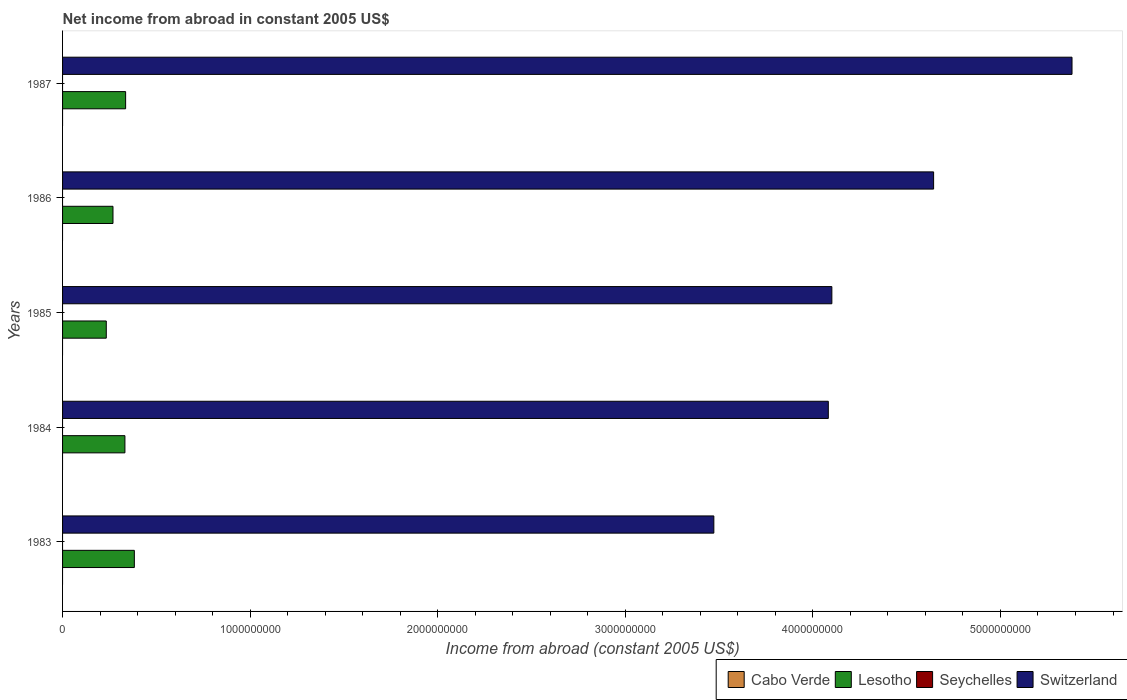Are the number of bars on each tick of the Y-axis equal?
Give a very brief answer. Yes. In how many cases, is the number of bars for a given year not equal to the number of legend labels?
Provide a short and direct response. 5. What is the net income from abroad in Cabo Verde in 1987?
Give a very brief answer. 0. Across all years, what is the maximum net income from abroad in Lesotho?
Keep it short and to the point. 3.83e+08. Across all years, what is the minimum net income from abroad in Lesotho?
Your answer should be very brief. 2.33e+08. What is the difference between the net income from abroad in Lesotho in 1983 and that in 1985?
Give a very brief answer. 1.50e+08. What is the difference between the net income from abroad in Cabo Verde in 1986 and the net income from abroad in Switzerland in 1984?
Offer a very short reply. -4.08e+09. In the year 1983, what is the difference between the net income from abroad in Lesotho and net income from abroad in Switzerland?
Provide a succinct answer. -3.09e+09. What is the ratio of the net income from abroad in Switzerland in 1983 to that in 1986?
Provide a short and direct response. 0.75. Is the difference between the net income from abroad in Lesotho in 1984 and 1986 greater than the difference between the net income from abroad in Switzerland in 1984 and 1986?
Provide a succinct answer. Yes. What is the difference between the highest and the second highest net income from abroad in Switzerland?
Your answer should be compact. 7.38e+08. What is the difference between the highest and the lowest net income from abroad in Lesotho?
Offer a very short reply. 1.50e+08. Is it the case that in every year, the sum of the net income from abroad in Lesotho and net income from abroad in Seychelles is greater than the sum of net income from abroad in Switzerland and net income from abroad in Cabo Verde?
Keep it short and to the point. No. How many bars are there?
Ensure brevity in your answer.  10. Are all the bars in the graph horizontal?
Ensure brevity in your answer.  Yes. How many years are there in the graph?
Your answer should be compact. 5. Are the values on the major ticks of X-axis written in scientific E-notation?
Keep it short and to the point. No. How many legend labels are there?
Your response must be concise. 4. What is the title of the graph?
Offer a very short reply. Net income from abroad in constant 2005 US$. What is the label or title of the X-axis?
Offer a very short reply. Income from abroad (constant 2005 US$). What is the Income from abroad (constant 2005 US$) in Lesotho in 1983?
Ensure brevity in your answer.  3.83e+08. What is the Income from abroad (constant 2005 US$) in Seychelles in 1983?
Your answer should be compact. 0. What is the Income from abroad (constant 2005 US$) of Switzerland in 1983?
Your answer should be very brief. 3.47e+09. What is the Income from abroad (constant 2005 US$) in Lesotho in 1984?
Provide a succinct answer. 3.32e+08. What is the Income from abroad (constant 2005 US$) in Seychelles in 1984?
Provide a succinct answer. 0. What is the Income from abroad (constant 2005 US$) of Switzerland in 1984?
Your answer should be very brief. 4.08e+09. What is the Income from abroad (constant 2005 US$) of Lesotho in 1985?
Ensure brevity in your answer.  2.33e+08. What is the Income from abroad (constant 2005 US$) in Seychelles in 1985?
Your response must be concise. 0. What is the Income from abroad (constant 2005 US$) in Switzerland in 1985?
Offer a very short reply. 4.10e+09. What is the Income from abroad (constant 2005 US$) of Cabo Verde in 1986?
Offer a very short reply. 0. What is the Income from abroad (constant 2005 US$) of Lesotho in 1986?
Your response must be concise. 2.69e+08. What is the Income from abroad (constant 2005 US$) in Seychelles in 1986?
Provide a succinct answer. 0. What is the Income from abroad (constant 2005 US$) in Switzerland in 1986?
Make the answer very short. 4.64e+09. What is the Income from abroad (constant 2005 US$) in Lesotho in 1987?
Ensure brevity in your answer.  3.36e+08. What is the Income from abroad (constant 2005 US$) of Switzerland in 1987?
Offer a very short reply. 5.38e+09. Across all years, what is the maximum Income from abroad (constant 2005 US$) of Lesotho?
Make the answer very short. 3.83e+08. Across all years, what is the maximum Income from abroad (constant 2005 US$) of Switzerland?
Offer a terse response. 5.38e+09. Across all years, what is the minimum Income from abroad (constant 2005 US$) in Lesotho?
Provide a succinct answer. 2.33e+08. Across all years, what is the minimum Income from abroad (constant 2005 US$) of Switzerland?
Provide a succinct answer. 3.47e+09. What is the total Income from abroad (constant 2005 US$) in Lesotho in the graph?
Your answer should be compact. 1.55e+09. What is the total Income from abroad (constant 2005 US$) in Seychelles in the graph?
Offer a terse response. 0. What is the total Income from abroad (constant 2005 US$) of Switzerland in the graph?
Keep it short and to the point. 2.17e+1. What is the difference between the Income from abroad (constant 2005 US$) of Lesotho in 1983 and that in 1984?
Your answer should be compact. 5.02e+07. What is the difference between the Income from abroad (constant 2005 US$) of Switzerland in 1983 and that in 1984?
Your answer should be very brief. -6.10e+08. What is the difference between the Income from abroad (constant 2005 US$) in Lesotho in 1983 and that in 1985?
Make the answer very short. 1.50e+08. What is the difference between the Income from abroad (constant 2005 US$) in Switzerland in 1983 and that in 1985?
Provide a succinct answer. -6.29e+08. What is the difference between the Income from abroad (constant 2005 US$) of Lesotho in 1983 and that in 1986?
Make the answer very short. 1.14e+08. What is the difference between the Income from abroad (constant 2005 US$) of Switzerland in 1983 and that in 1986?
Keep it short and to the point. -1.17e+09. What is the difference between the Income from abroad (constant 2005 US$) of Lesotho in 1983 and that in 1987?
Your answer should be compact. 4.65e+07. What is the difference between the Income from abroad (constant 2005 US$) in Switzerland in 1983 and that in 1987?
Offer a terse response. -1.91e+09. What is the difference between the Income from abroad (constant 2005 US$) of Lesotho in 1984 and that in 1985?
Ensure brevity in your answer.  9.94e+07. What is the difference between the Income from abroad (constant 2005 US$) in Switzerland in 1984 and that in 1985?
Offer a terse response. -1.90e+07. What is the difference between the Income from abroad (constant 2005 US$) in Lesotho in 1984 and that in 1986?
Your answer should be compact. 6.36e+07. What is the difference between the Income from abroad (constant 2005 US$) of Switzerland in 1984 and that in 1986?
Make the answer very short. -5.61e+08. What is the difference between the Income from abroad (constant 2005 US$) of Lesotho in 1984 and that in 1987?
Provide a short and direct response. -3.77e+06. What is the difference between the Income from abroad (constant 2005 US$) of Switzerland in 1984 and that in 1987?
Keep it short and to the point. -1.30e+09. What is the difference between the Income from abroad (constant 2005 US$) of Lesotho in 1985 and that in 1986?
Offer a terse response. -3.58e+07. What is the difference between the Income from abroad (constant 2005 US$) in Switzerland in 1985 and that in 1986?
Give a very brief answer. -5.42e+08. What is the difference between the Income from abroad (constant 2005 US$) in Lesotho in 1985 and that in 1987?
Offer a terse response. -1.03e+08. What is the difference between the Income from abroad (constant 2005 US$) in Switzerland in 1985 and that in 1987?
Your response must be concise. -1.28e+09. What is the difference between the Income from abroad (constant 2005 US$) in Lesotho in 1986 and that in 1987?
Your response must be concise. -6.73e+07. What is the difference between the Income from abroad (constant 2005 US$) in Switzerland in 1986 and that in 1987?
Provide a succinct answer. -7.38e+08. What is the difference between the Income from abroad (constant 2005 US$) of Lesotho in 1983 and the Income from abroad (constant 2005 US$) of Switzerland in 1984?
Ensure brevity in your answer.  -3.70e+09. What is the difference between the Income from abroad (constant 2005 US$) in Lesotho in 1983 and the Income from abroad (constant 2005 US$) in Switzerland in 1985?
Keep it short and to the point. -3.72e+09. What is the difference between the Income from abroad (constant 2005 US$) of Lesotho in 1983 and the Income from abroad (constant 2005 US$) of Switzerland in 1986?
Your response must be concise. -4.26e+09. What is the difference between the Income from abroad (constant 2005 US$) in Lesotho in 1983 and the Income from abroad (constant 2005 US$) in Switzerland in 1987?
Keep it short and to the point. -5.00e+09. What is the difference between the Income from abroad (constant 2005 US$) in Lesotho in 1984 and the Income from abroad (constant 2005 US$) in Switzerland in 1985?
Give a very brief answer. -3.77e+09. What is the difference between the Income from abroad (constant 2005 US$) in Lesotho in 1984 and the Income from abroad (constant 2005 US$) in Switzerland in 1986?
Provide a short and direct response. -4.31e+09. What is the difference between the Income from abroad (constant 2005 US$) of Lesotho in 1984 and the Income from abroad (constant 2005 US$) of Switzerland in 1987?
Offer a terse response. -5.05e+09. What is the difference between the Income from abroad (constant 2005 US$) of Lesotho in 1985 and the Income from abroad (constant 2005 US$) of Switzerland in 1986?
Ensure brevity in your answer.  -4.41e+09. What is the difference between the Income from abroad (constant 2005 US$) in Lesotho in 1985 and the Income from abroad (constant 2005 US$) in Switzerland in 1987?
Your answer should be compact. -5.15e+09. What is the difference between the Income from abroad (constant 2005 US$) of Lesotho in 1986 and the Income from abroad (constant 2005 US$) of Switzerland in 1987?
Ensure brevity in your answer.  -5.11e+09. What is the average Income from abroad (constant 2005 US$) in Lesotho per year?
Provide a short and direct response. 3.11e+08. What is the average Income from abroad (constant 2005 US$) in Seychelles per year?
Make the answer very short. 0. What is the average Income from abroad (constant 2005 US$) of Switzerland per year?
Your answer should be compact. 4.34e+09. In the year 1983, what is the difference between the Income from abroad (constant 2005 US$) of Lesotho and Income from abroad (constant 2005 US$) of Switzerland?
Your answer should be compact. -3.09e+09. In the year 1984, what is the difference between the Income from abroad (constant 2005 US$) in Lesotho and Income from abroad (constant 2005 US$) in Switzerland?
Provide a succinct answer. -3.75e+09. In the year 1985, what is the difference between the Income from abroad (constant 2005 US$) in Lesotho and Income from abroad (constant 2005 US$) in Switzerland?
Offer a terse response. -3.87e+09. In the year 1986, what is the difference between the Income from abroad (constant 2005 US$) of Lesotho and Income from abroad (constant 2005 US$) of Switzerland?
Your answer should be very brief. -4.37e+09. In the year 1987, what is the difference between the Income from abroad (constant 2005 US$) in Lesotho and Income from abroad (constant 2005 US$) in Switzerland?
Keep it short and to the point. -5.05e+09. What is the ratio of the Income from abroad (constant 2005 US$) of Lesotho in 1983 to that in 1984?
Make the answer very short. 1.15. What is the ratio of the Income from abroad (constant 2005 US$) of Switzerland in 1983 to that in 1984?
Ensure brevity in your answer.  0.85. What is the ratio of the Income from abroad (constant 2005 US$) in Lesotho in 1983 to that in 1985?
Make the answer very short. 1.64. What is the ratio of the Income from abroad (constant 2005 US$) in Switzerland in 1983 to that in 1985?
Provide a succinct answer. 0.85. What is the ratio of the Income from abroad (constant 2005 US$) of Lesotho in 1983 to that in 1986?
Your answer should be very brief. 1.42. What is the ratio of the Income from abroad (constant 2005 US$) in Switzerland in 1983 to that in 1986?
Your answer should be very brief. 0.75. What is the ratio of the Income from abroad (constant 2005 US$) in Lesotho in 1983 to that in 1987?
Provide a succinct answer. 1.14. What is the ratio of the Income from abroad (constant 2005 US$) in Switzerland in 1983 to that in 1987?
Give a very brief answer. 0.65. What is the ratio of the Income from abroad (constant 2005 US$) of Lesotho in 1984 to that in 1985?
Your answer should be very brief. 1.43. What is the ratio of the Income from abroad (constant 2005 US$) in Switzerland in 1984 to that in 1985?
Ensure brevity in your answer.  1. What is the ratio of the Income from abroad (constant 2005 US$) in Lesotho in 1984 to that in 1986?
Offer a terse response. 1.24. What is the ratio of the Income from abroad (constant 2005 US$) in Switzerland in 1984 to that in 1986?
Offer a terse response. 0.88. What is the ratio of the Income from abroad (constant 2005 US$) in Switzerland in 1984 to that in 1987?
Offer a terse response. 0.76. What is the ratio of the Income from abroad (constant 2005 US$) in Lesotho in 1985 to that in 1986?
Your answer should be very brief. 0.87. What is the ratio of the Income from abroad (constant 2005 US$) of Switzerland in 1985 to that in 1986?
Provide a short and direct response. 0.88. What is the ratio of the Income from abroad (constant 2005 US$) in Lesotho in 1985 to that in 1987?
Keep it short and to the point. 0.69. What is the ratio of the Income from abroad (constant 2005 US$) in Switzerland in 1985 to that in 1987?
Make the answer very short. 0.76. What is the ratio of the Income from abroad (constant 2005 US$) of Lesotho in 1986 to that in 1987?
Offer a terse response. 0.8. What is the ratio of the Income from abroad (constant 2005 US$) of Switzerland in 1986 to that in 1987?
Ensure brevity in your answer.  0.86. What is the difference between the highest and the second highest Income from abroad (constant 2005 US$) in Lesotho?
Ensure brevity in your answer.  4.65e+07. What is the difference between the highest and the second highest Income from abroad (constant 2005 US$) of Switzerland?
Your response must be concise. 7.38e+08. What is the difference between the highest and the lowest Income from abroad (constant 2005 US$) in Lesotho?
Your answer should be very brief. 1.50e+08. What is the difference between the highest and the lowest Income from abroad (constant 2005 US$) in Switzerland?
Provide a succinct answer. 1.91e+09. 